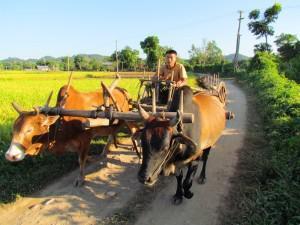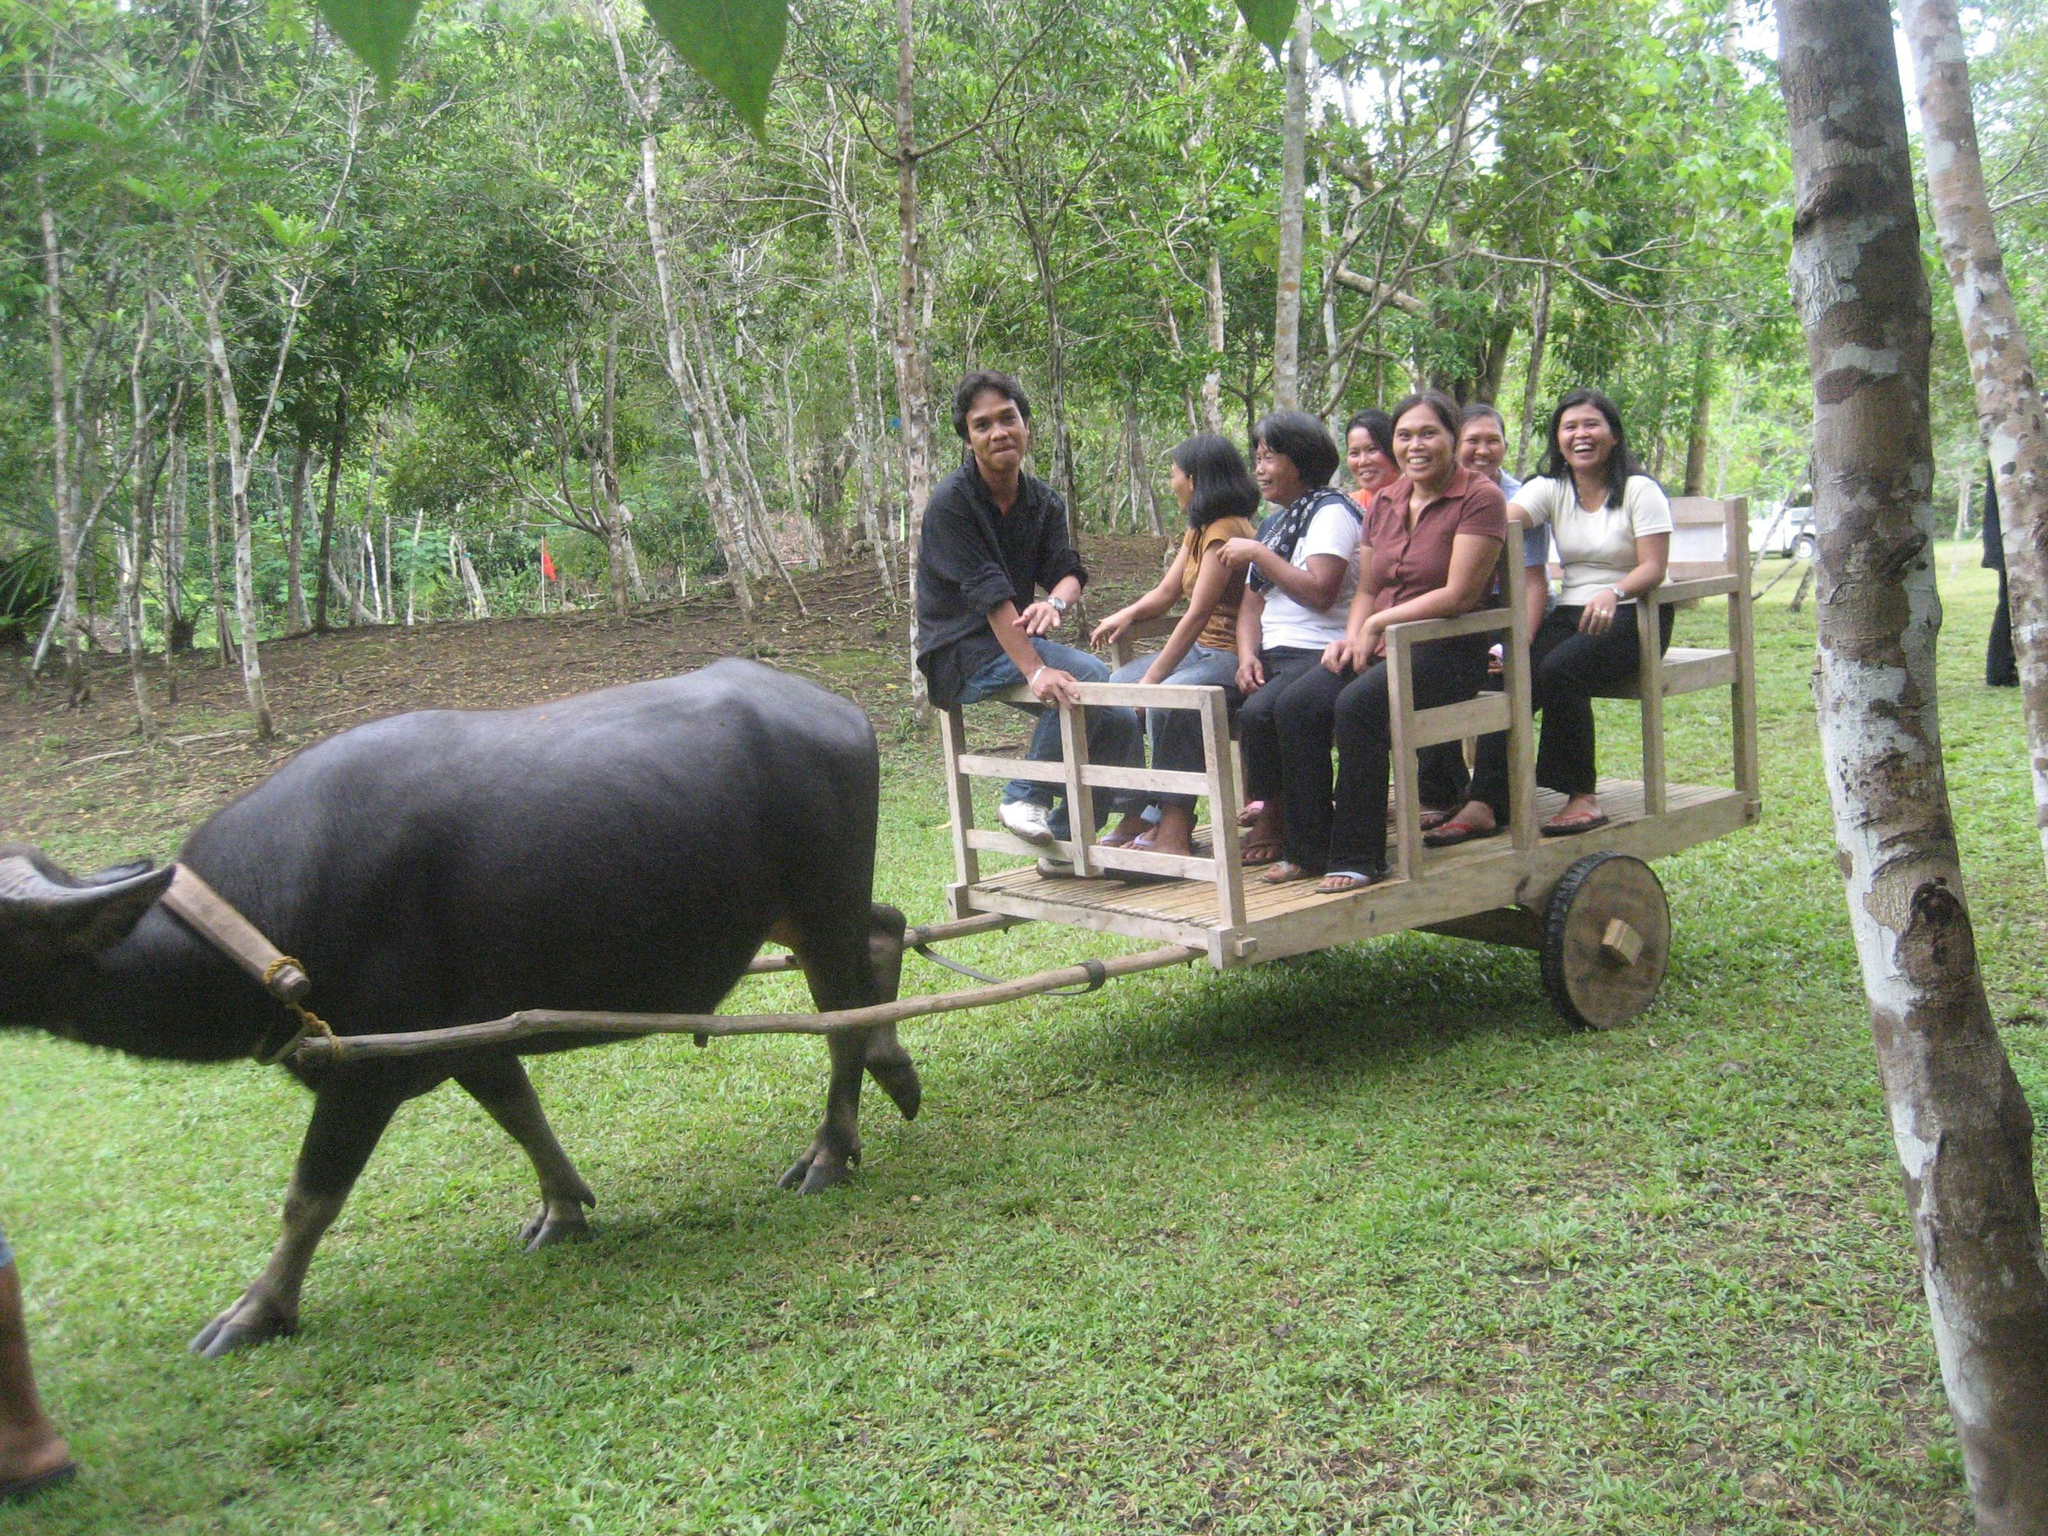The first image is the image on the left, the second image is the image on the right. Assess this claim about the two images: "a pair of oxen are pulling a cart down a dirt path". Correct or not? Answer yes or no. Yes. The first image is the image on the left, the second image is the image on the right. Considering the images on both sides, is "The image on the right shows a single ox drawing a cart." valid? Answer yes or no. Yes. 